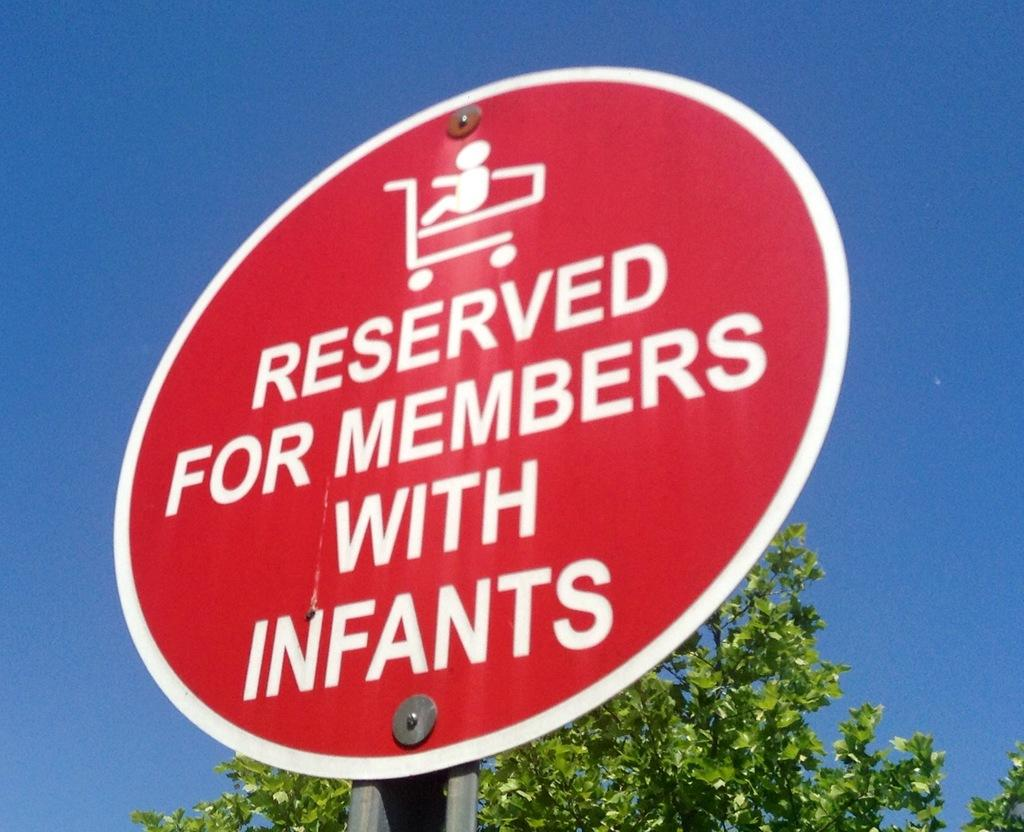<image>
Write a terse but informative summary of the picture. A round red sign indicates the space is reserved for members with infants. 